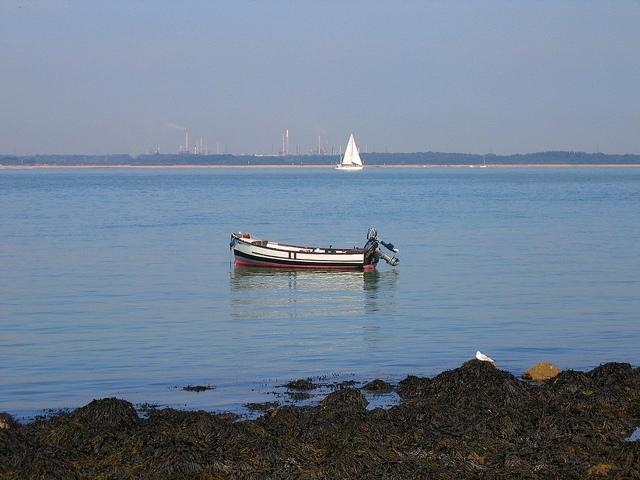What is in the background?
From the following four choices, select the correct answer to address the question.
Options: Palm tree, sailboat, fisherman, baby. Sailboat. 